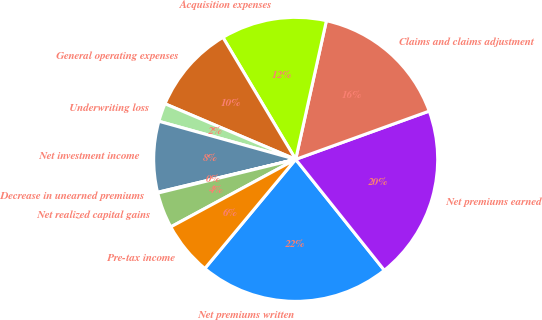Convert chart. <chart><loc_0><loc_0><loc_500><loc_500><pie_chart><fcel>Net premiums written<fcel>Net premiums earned<fcel>Claims and claims adjustment<fcel>Acquisition expenses<fcel>General operating expenses<fcel>Underwriting loss<fcel>Net investment income<fcel>Decrease in unearned premiums<fcel>Net realized capital gains<fcel>Pre-tax income<nl><fcel>21.78%<fcel>19.79%<fcel>16.01%<fcel>12.03%<fcel>10.04%<fcel>2.08%<fcel>8.05%<fcel>0.09%<fcel>4.07%<fcel>6.06%<nl></chart> 